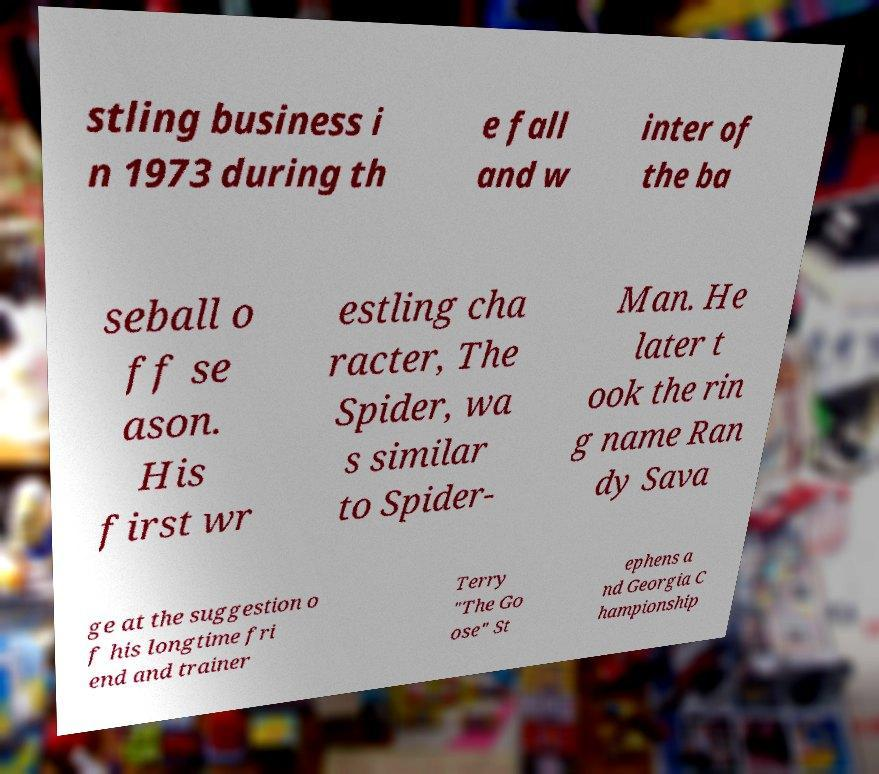Can you accurately transcribe the text from the provided image for me? stling business i n 1973 during th e fall and w inter of the ba seball o ff se ason. His first wr estling cha racter, The Spider, wa s similar to Spider- Man. He later t ook the rin g name Ran dy Sava ge at the suggestion o f his longtime fri end and trainer Terry "The Go ose" St ephens a nd Georgia C hampionship 